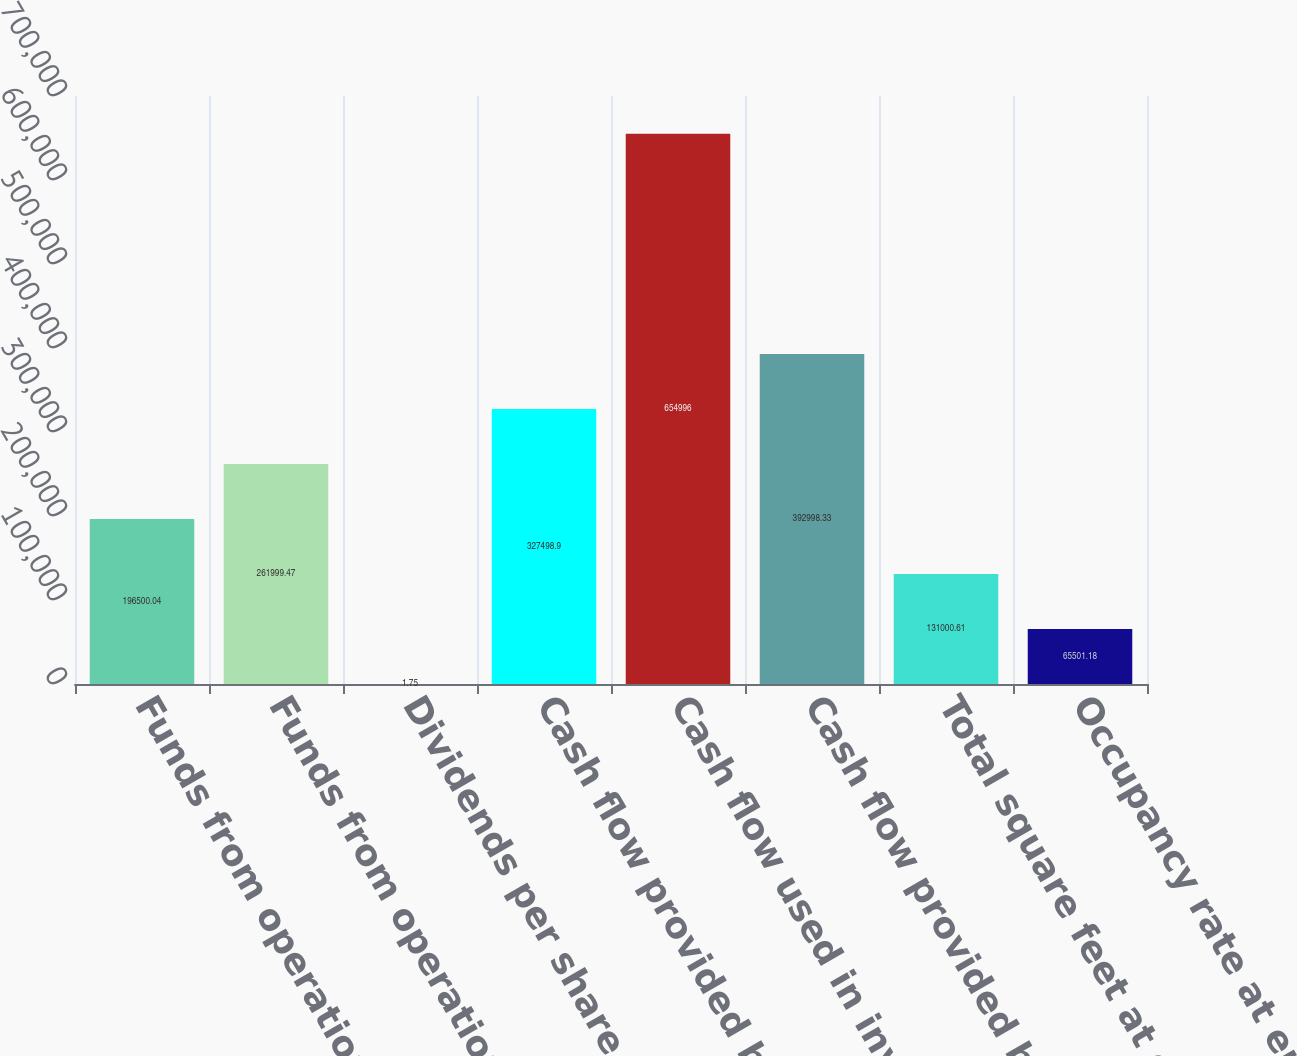Convert chart to OTSL. <chart><loc_0><loc_0><loc_500><loc_500><bar_chart><fcel>Funds from operations(1)<fcel>Funds from operations as<fcel>Dividends per share<fcel>Cash flow provided by<fcel>Cash flow used in investing<fcel>Cash flow provided by (used<fcel>Total square feet at end of<fcel>Occupancy rate at end of year<nl><fcel>196500<fcel>261999<fcel>1.75<fcel>327499<fcel>654996<fcel>392998<fcel>131001<fcel>65501.2<nl></chart> 